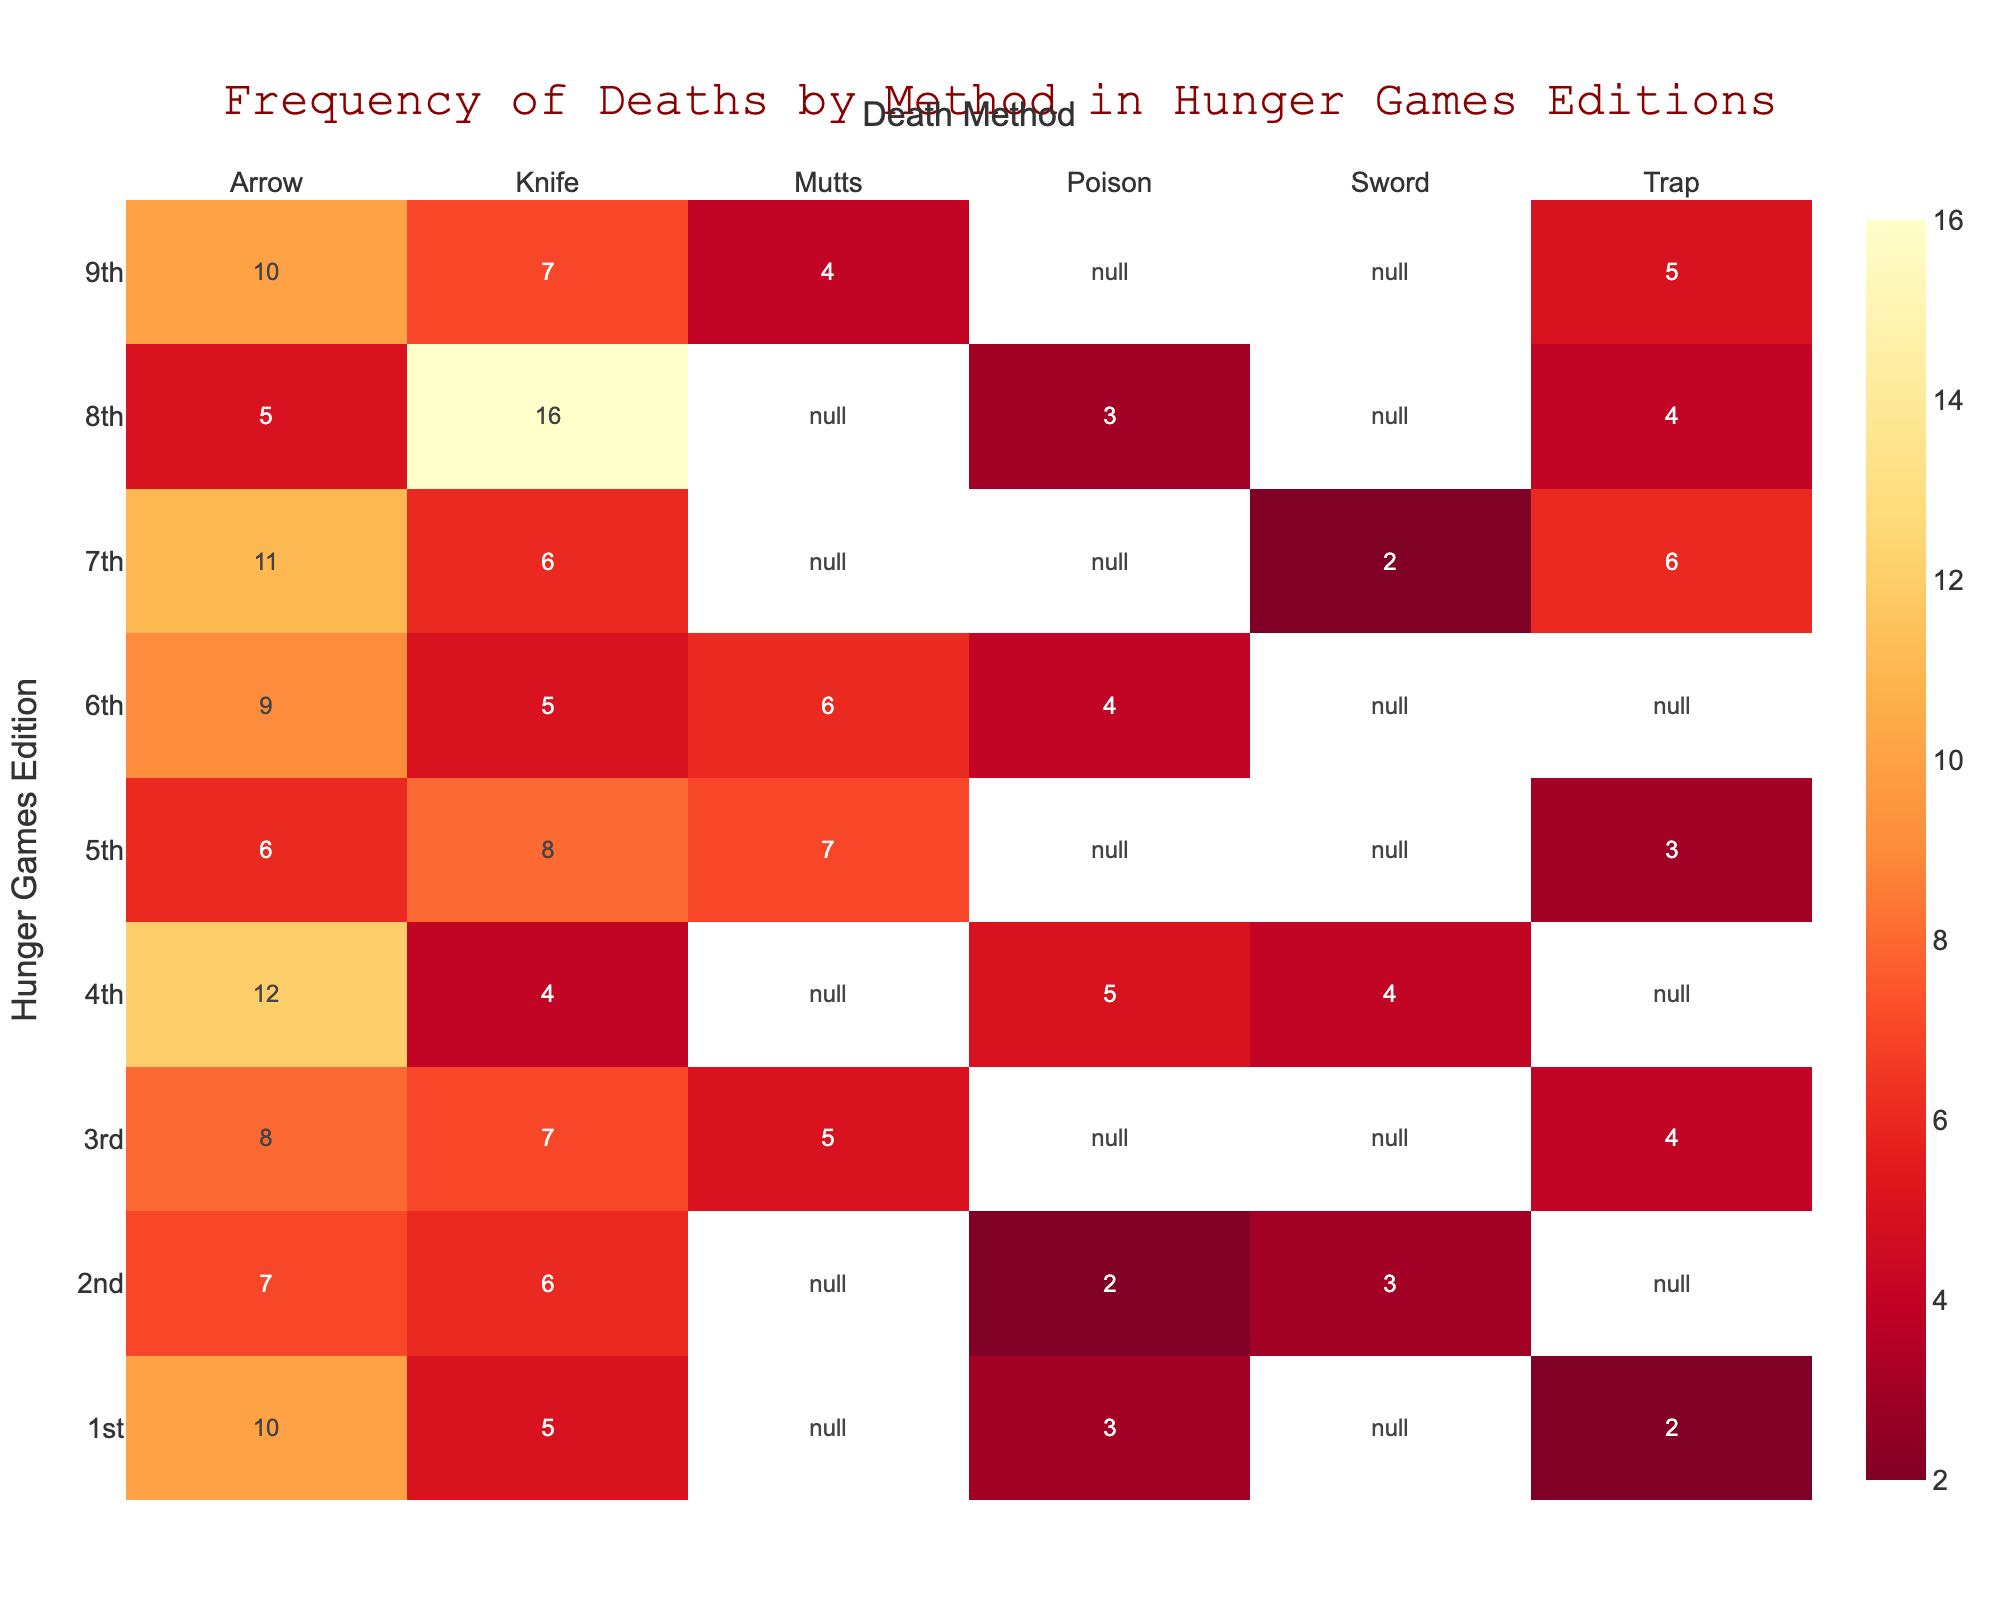What is the title of the heatmap? The title is located at the top center of the heatmap. By reading it, we can determine the title of the figure.
Answer: Frequency of Deaths by Method in Hunger Games Editions Which Hunger Games edition had the highest number of deaths caused by arrows? By locating the 'Arrow' column and scanning through its rows, we identify the edition with the highest count.
Answer: 4th What is the total number of deaths caused by mutts? By summing all the values in the 'Mutts' column, we get the total number of deaths caused by mutts. This involves summing the counts for the 3rd, 5th, 6th, and 9th editions. (5 + 7 + 6 + 4 = 22)
Answer: 22 Which method resulted in the most deaths in the 8th Hunger Games edition? By locating the row for the 8th edition and scanning across the methods, we identify the method with the highest count.
Answer: Knife How many more deaths were caused by poison in the 6th edition compared to the 2nd edition? By locating the 'Poison' column and finding the counts for the 6th and 2nd editions, we calculate the difference (4 - 2 = 2).
Answer: 2 Which two methods had an equal number of deaths in the 4th Hunger Games edition? By examining the row for the 4th edition, we look for matching counts between different methods.
Answer: Knife and Sword What is the average number of deaths caused by arrows across all editions? By summing the values in the 'Arrow' column and dividing by the number of editions (10), we calculate the average. (10+7+8+12+6+9+11+5+10)/9 = 78/9 ≈ 8.67
Answer: 8.67 Which edition reported the lowest number of deaths due to traps? By locating the 'Trap' column and scanning through its rows, we identify the edition with the lowest count.
Answer: 1st In which edition did the total number of deaths (sum of all methods) reach its peak? By summing the counts across all methods for each edition and comparing the totals, we determine the edition with the highest sum.
Answer: 8th Are there any editions where the total count of deaths is the same for methods "Arrow" and "Knife"? By comparing the counts for 'Arrow' and 'Knife' across all editions, we look for any rows where the counts are equal.
Answer: No 